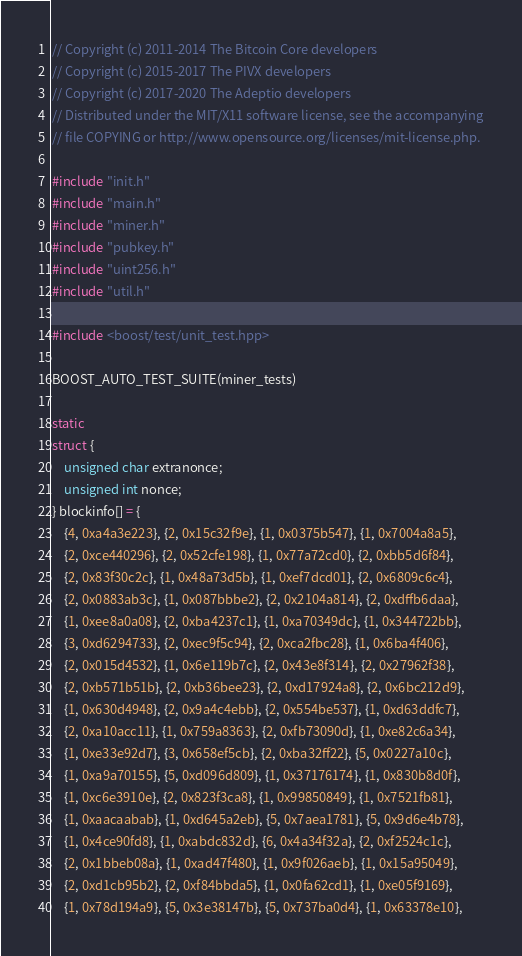Convert code to text. <code><loc_0><loc_0><loc_500><loc_500><_C++_>// Copyright (c) 2011-2014 The Bitcoin Core developers
// Copyright (c) 2015-2017 The PIVX developers// Copyright (c) 2017-2020 The Adeptio developers
// Distributed under the MIT/X11 software license, see the accompanying
// file COPYING or http://www.opensource.org/licenses/mit-license.php.

#include "init.h"
#include "main.h"
#include "miner.h"
#include "pubkey.h"
#include "uint256.h"
#include "util.h"

#include <boost/test/unit_test.hpp>

BOOST_AUTO_TEST_SUITE(miner_tests)

static
struct {
    unsigned char extranonce;
    unsigned int nonce;
} blockinfo[] = {
    {4, 0xa4a3e223}, {2, 0x15c32f9e}, {1, 0x0375b547}, {1, 0x7004a8a5},
    {2, 0xce440296}, {2, 0x52cfe198}, {1, 0x77a72cd0}, {2, 0xbb5d6f84},
    {2, 0x83f30c2c}, {1, 0x48a73d5b}, {1, 0xef7dcd01}, {2, 0x6809c6c4},
    {2, 0x0883ab3c}, {1, 0x087bbbe2}, {2, 0x2104a814}, {2, 0xdffb6daa},
    {1, 0xee8a0a08}, {2, 0xba4237c1}, {1, 0xa70349dc}, {1, 0x344722bb},
    {3, 0xd6294733}, {2, 0xec9f5c94}, {2, 0xca2fbc28}, {1, 0x6ba4f406},
    {2, 0x015d4532}, {1, 0x6e119b7c}, {2, 0x43e8f314}, {2, 0x27962f38},
    {2, 0xb571b51b}, {2, 0xb36bee23}, {2, 0xd17924a8}, {2, 0x6bc212d9},
    {1, 0x630d4948}, {2, 0x9a4c4ebb}, {2, 0x554be537}, {1, 0xd63ddfc7},
    {2, 0xa10acc11}, {1, 0x759a8363}, {2, 0xfb73090d}, {1, 0xe82c6a34},
    {1, 0xe33e92d7}, {3, 0x658ef5cb}, {2, 0xba32ff22}, {5, 0x0227a10c},
    {1, 0xa9a70155}, {5, 0xd096d809}, {1, 0x37176174}, {1, 0x830b8d0f},
    {1, 0xc6e3910e}, {2, 0x823f3ca8}, {1, 0x99850849}, {1, 0x7521fb81},
    {1, 0xaacaabab}, {1, 0xd645a2eb}, {5, 0x7aea1781}, {5, 0x9d6e4b78},
    {1, 0x4ce90fd8}, {1, 0xabdc832d}, {6, 0x4a34f32a}, {2, 0xf2524c1c},
    {2, 0x1bbeb08a}, {1, 0xad47f480}, {1, 0x9f026aeb}, {1, 0x15a95049},
    {2, 0xd1cb95b2}, {2, 0xf84bbda5}, {1, 0x0fa62cd1}, {1, 0xe05f9169},
    {1, 0x78d194a9}, {5, 0x3e38147b}, {5, 0x737ba0d4}, {1, 0x63378e10},</code> 